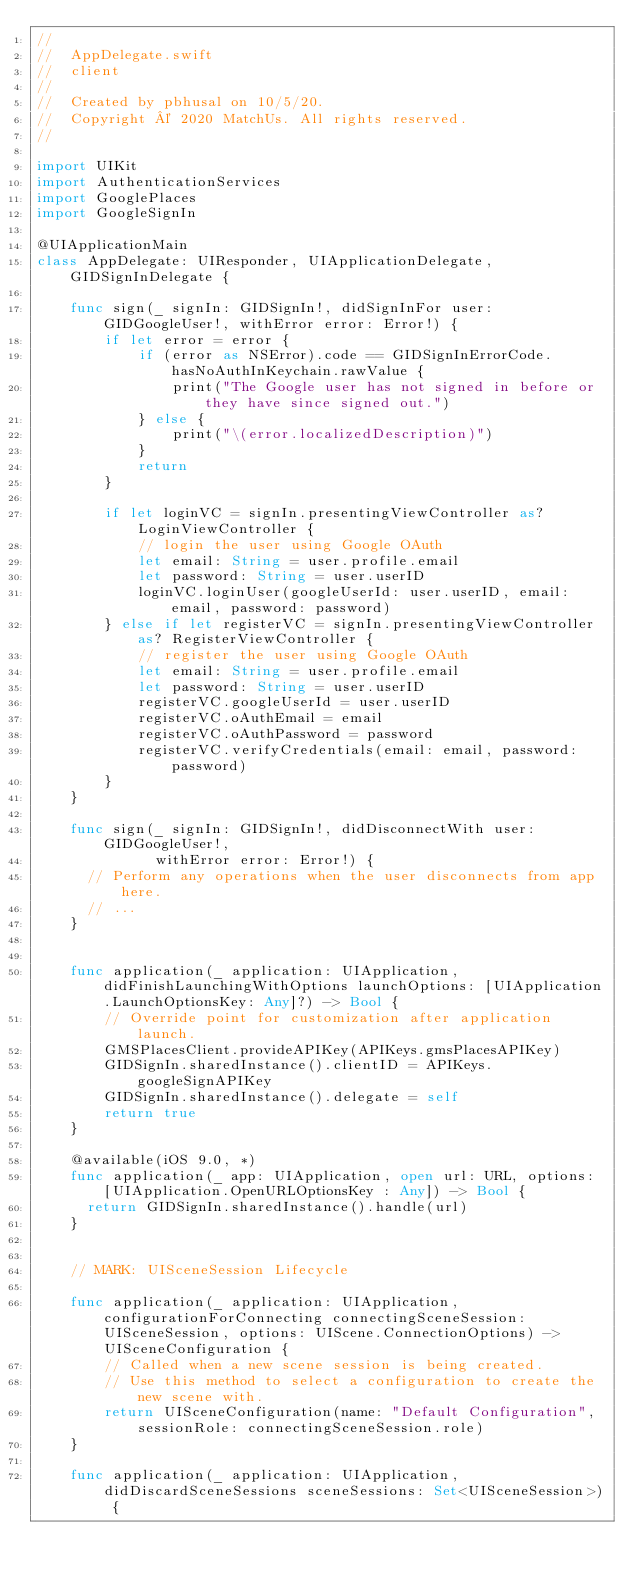Convert code to text. <code><loc_0><loc_0><loc_500><loc_500><_Swift_>//
//  AppDelegate.swift
//  client
//
//  Created by pbhusal on 10/5/20.
//  Copyright © 2020 MatchUs. All rights reserved.
//

import UIKit
import AuthenticationServices
import GooglePlaces
import GoogleSignIn

@UIApplicationMain
class AppDelegate: UIResponder, UIApplicationDelegate, GIDSignInDelegate {
    
    func sign(_ signIn: GIDSignIn!, didSignInFor user: GIDGoogleUser!, withError error: Error!) {
        if let error = error {
            if (error as NSError).code == GIDSignInErrorCode.hasNoAuthInKeychain.rawValue {
                print("The Google user has not signed in before or they have since signed out.")
            } else {
                print("\(error.localizedDescription)")
            }
            return
        }
        
        if let loginVC = signIn.presentingViewController as? LoginViewController {
            // login the user using Google OAuth
            let email: String = user.profile.email
            let password: String = user.userID
            loginVC.loginUser(googleUserId: user.userID, email: email, password: password)
        } else if let registerVC = signIn.presentingViewController as? RegisterViewController {
            // register the user using Google OAuth
            let email: String = user.profile.email
            let password: String = user.userID
            registerVC.googleUserId = user.userID
            registerVC.oAuthEmail = email
            registerVC.oAuthPassword = password
            registerVC.verifyCredentials(email: email, password: password)
        }
    }
    
    func sign(_ signIn: GIDSignIn!, didDisconnectWith user: GIDGoogleUser!,
              withError error: Error!) {
      // Perform any operations when the user disconnects from app here.
      // ...
    }
    

    func application(_ application: UIApplication, didFinishLaunchingWithOptions launchOptions: [UIApplication.LaunchOptionsKey: Any]?) -> Bool {
        // Override point for customization after application launch.
        GMSPlacesClient.provideAPIKey(APIKeys.gmsPlacesAPIKey)
        GIDSignIn.sharedInstance().clientID = APIKeys.googleSignAPIKey
        GIDSignIn.sharedInstance().delegate = self
        return true
    }
    
    @available(iOS 9.0, *)
    func application(_ app: UIApplication, open url: URL, options: [UIApplication.OpenURLOptionsKey : Any]) -> Bool {
      return GIDSignIn.sharedInstance().handle(url)
    }


    // MARK: UISceneSession Lifecycle

    func application(_ application: UIApplication, configurationForConnecting connectingSceneSession: UISceneSession, options: UIScene.ConnectionOptions) -> UISceneConfiguration {
        // Called when a new scene session is being created.
        // Use this method to select a configuration to create the new scene with.
        return UISceneConfiguration(name: "Default Configuration", sessionRole: connectingSceneSession.role)
    }

    func application(_ application: UIApplication, didDiscardSceneSessions sceneSessions: Set<UISceneSession>) {</code> 